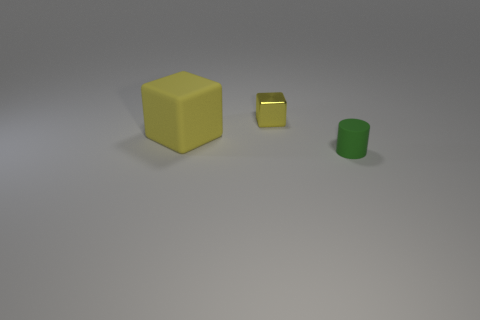Add 2 matte objects. How many objects exist? 5 Subtract all cubes. How many objects are left? 1 Subtract 1 blocks. How many blocks are left? 1 Subtract all red cubes. Subtract all yellow balls. How many cubes are left? 2 Subtract all brown balls. How many cyan cylinders are left? 0 Subtract all metal things. Subtract all purple rubber blocks. How many objects are left? 2 Add 2 green things. How many green things are left? 3 Add 3 tiny blue cubes. How many tiny blue cubes exist? 3 Subtract 0 purple cylinders. How many objects are left? 3 